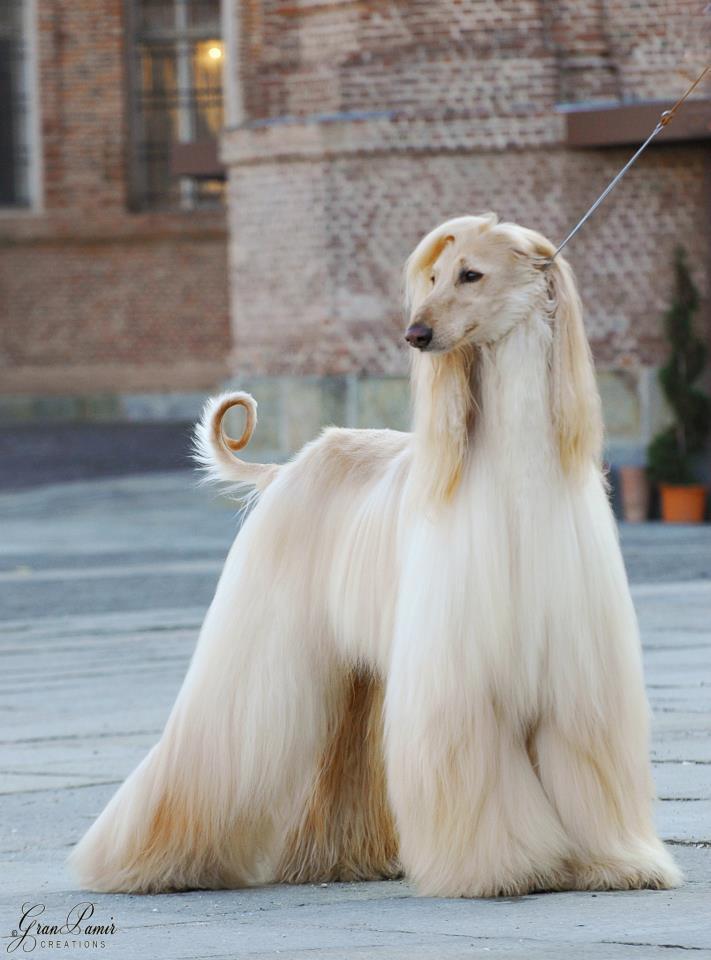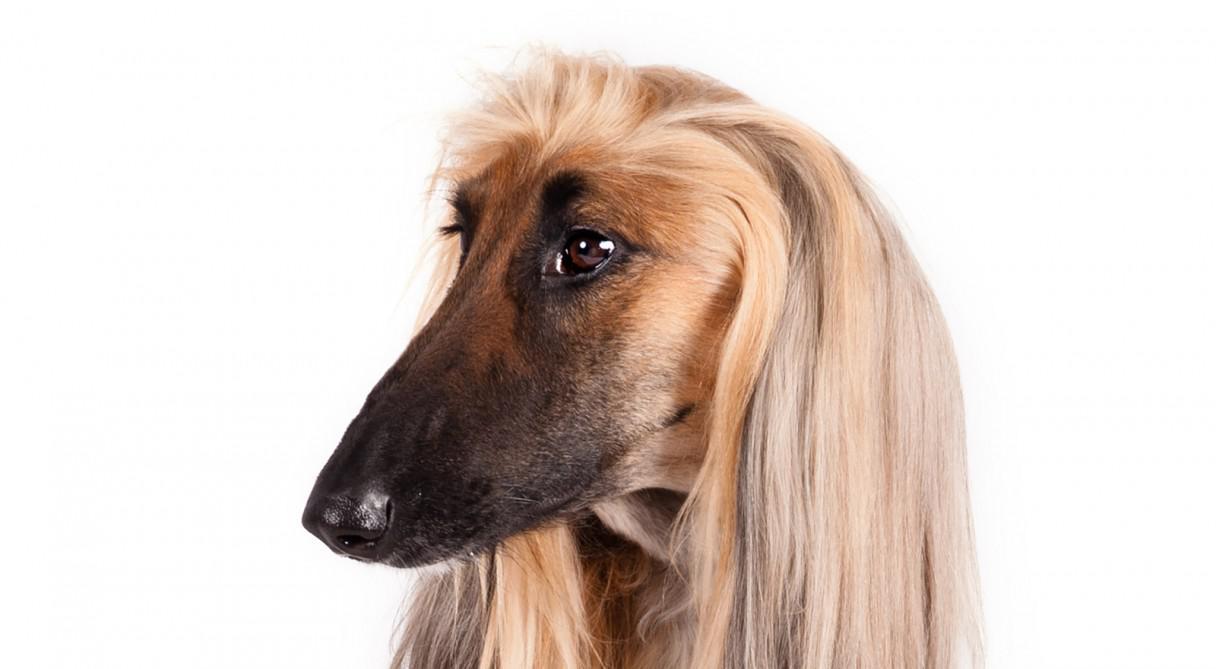The first image is the image on the left, the second image is the image on the right. Examine the images to the left and right. Is the description "There is at least one dog standing on all fours in the image on the left." accurate? Answer yes or no. Yes. The first image is the image on the left, the second image is the image on the right. Given the left and right images, does the statement "An image shows a standing dog with a leash attached." hold true? Answer yes or no. Yes. 